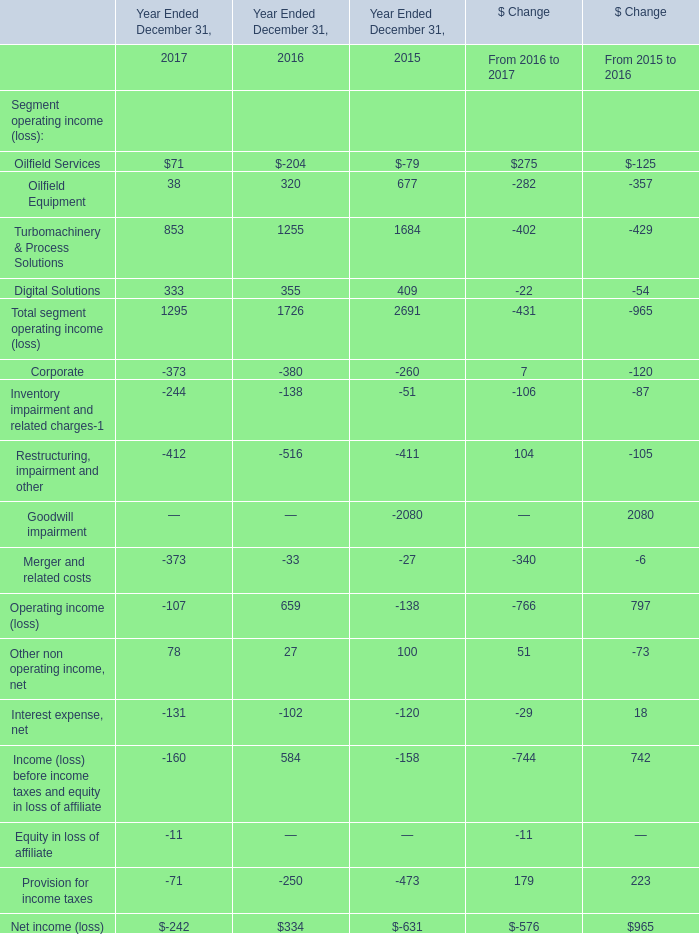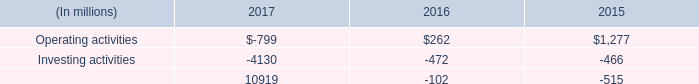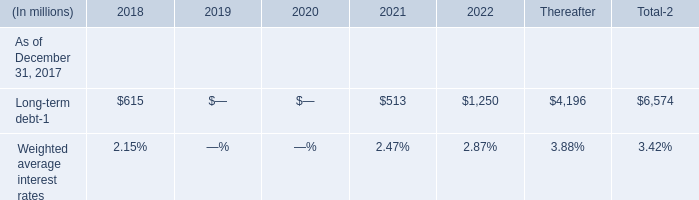what is the net change in cash during 2015? 
Computations: ((1277 + -466) + -515)
Answer: 296.0. 